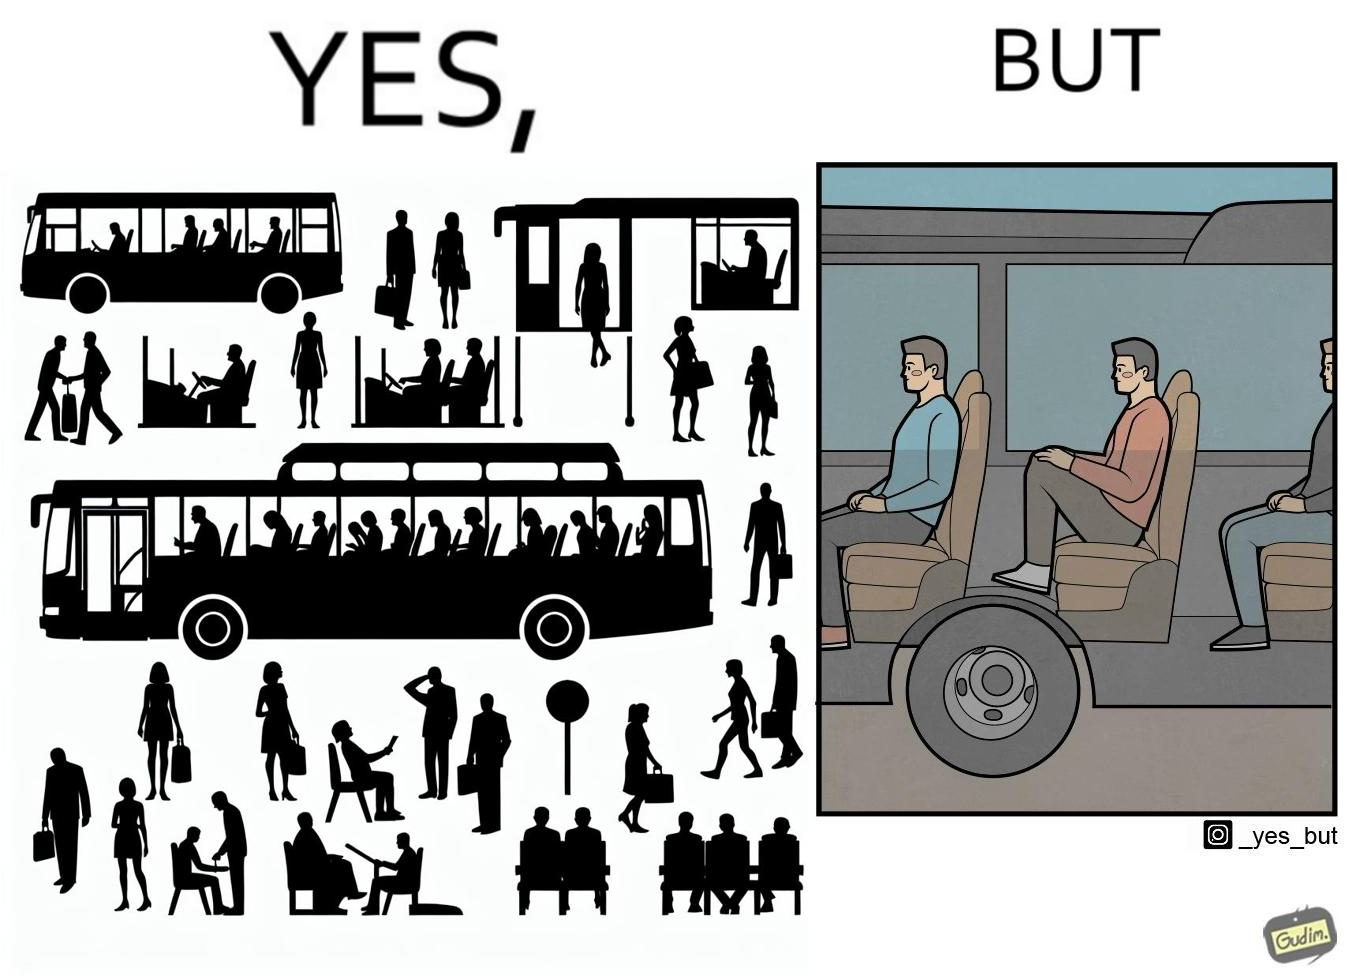Describe the satirical element in this image. the irony in this image is that the seat right above a bus' wheels is the most uncomfortable one. 